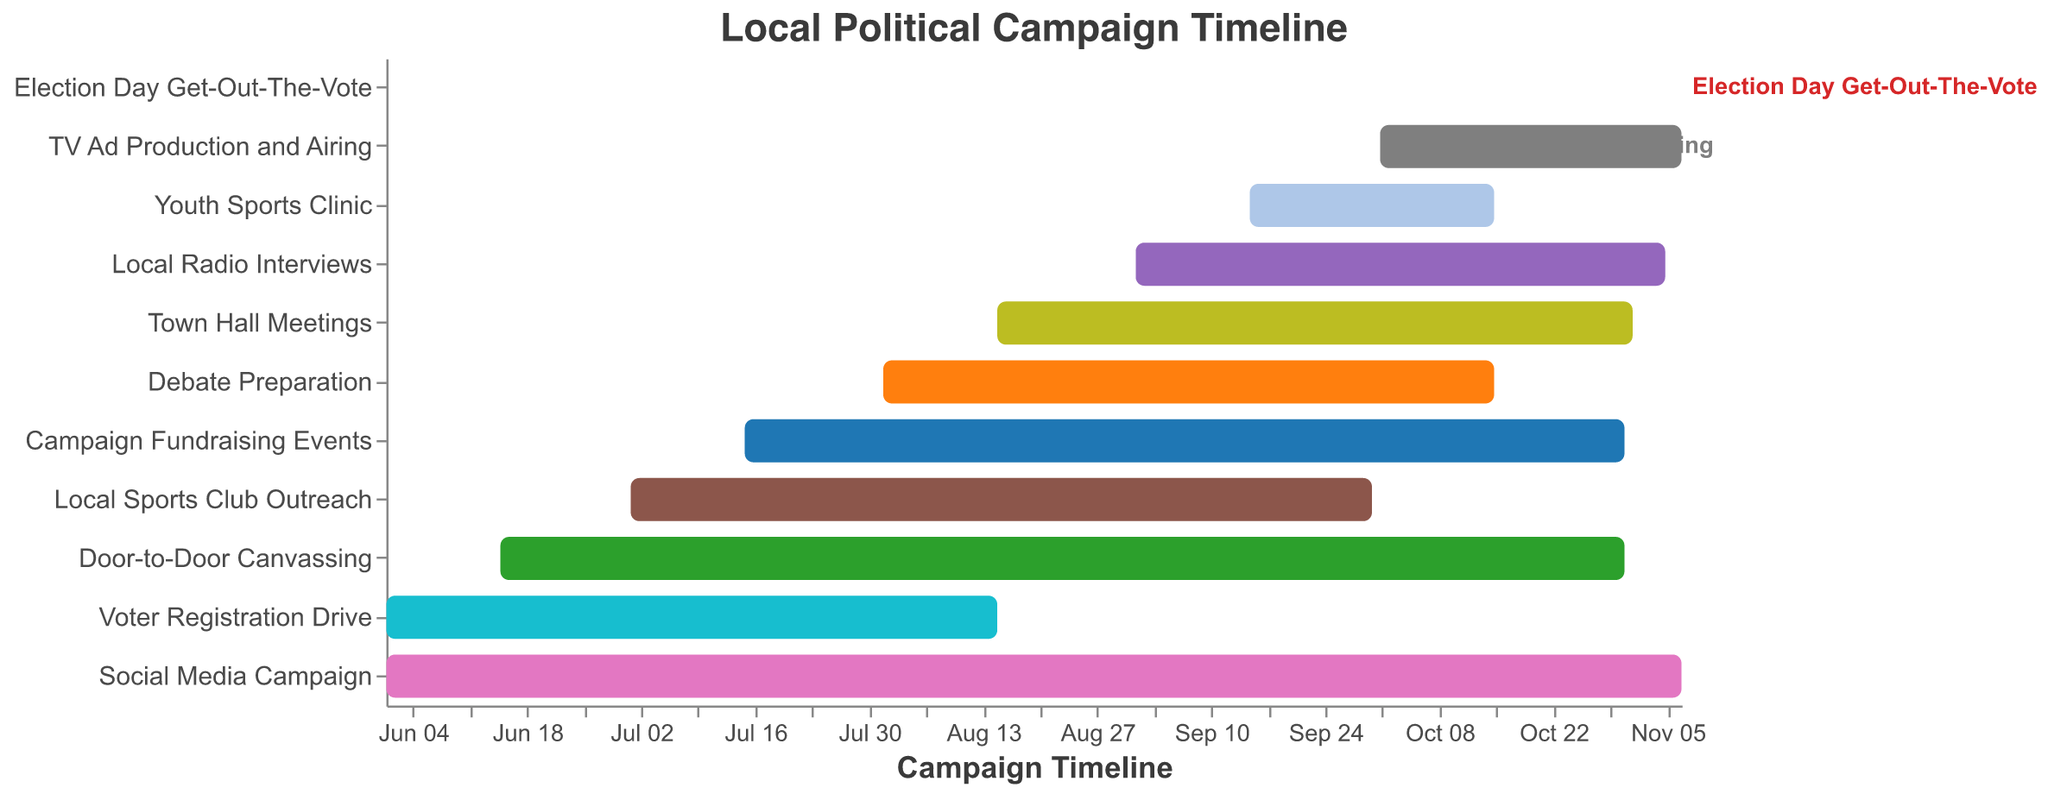Which task spans the entire duration of the campaign? Look for the task that has the earliest start date and the latest end date. The "Social Media Campaign" starts on 2023-06-01 and ends on 2023-11-07.
Answer: Social Media Campaign When does the local sports club outreach start and end? Locate the task "Local Sports Club Outreach" on the Gantt chart, and note its start and end dates: 2023-07-01 to 2023-09-30.
Answer: 2023-07-01 to 2023-09-30 Which two tasks end simultaneously? Look for tasks with the same end date. Both "Door-to-Door Canvassing" and "Campaign Fundraising Events" end on 2023-10-31.
Answer: Door-to-Door Canvassing and Campaign Fundraising Events How long is the duration of the debate preparation? Calculate the number of days from the start date to the end date for "Debate Preparation". From 2023-08-01 to 2023-10-15 is 76 days.
Answer: 76 days Which tasks overlap with the town hall meetings? Identify tasks that have dates intersecting with the timeline of "Town Hall Meetings" (2023-08-15 to 2023-11-01). These tasks are "Debate Preparation", "Social Media Campaign", "Local Radio Interviews", "Campaign Fundraising Events", "Youth Sports Clinic", "TV Ad Production and Airing", and "Election Day Get-Out-The-Vote".
Answer: Debate Preparation, Social Media Campaign, Local Radio Interviews, Campaign Fundraising Events, Youth Sports Clinic, TV Ad Production and Airing, Election Day Get-Out-The-Vote If you were to prioritize tasks involving direct voter engagement starting September, which ones would you focus on? Consider tasks starting or continuing in September that involve direct voter engagement: "Local Radio Interviews", "Youth Sports Clinic", "Door-to-Door Canvassing", and "Election Day Get-Out-The-Vote".
Answer: Local Radio Interviews, Youth Sports Clinic, Door-to-Door Canvassing, Election Day Get-Out-The-Vote How many tasks start after August 15, 2023? Count the tasks that have start dates after 2023-08-15. They are "Local Radio Interviews", "Youth Sports Clinic", "TV Ad Production and Airing", and "Election Day Get-Out-The-Vote".
Answer: 4 tasks What is the maximum overlap duration between any two tasks? Identify the two tasks that overlap the most and calculate their overlapping period. "Door-to-Door Canvassing" (2023-06-15 to 2023-10-31) and "Social Media Campaign" (2023-06-01 to 2023-11-07) overlap for 138 days (2023-06-15 to 2023-10-31).
Answer: 138 days 